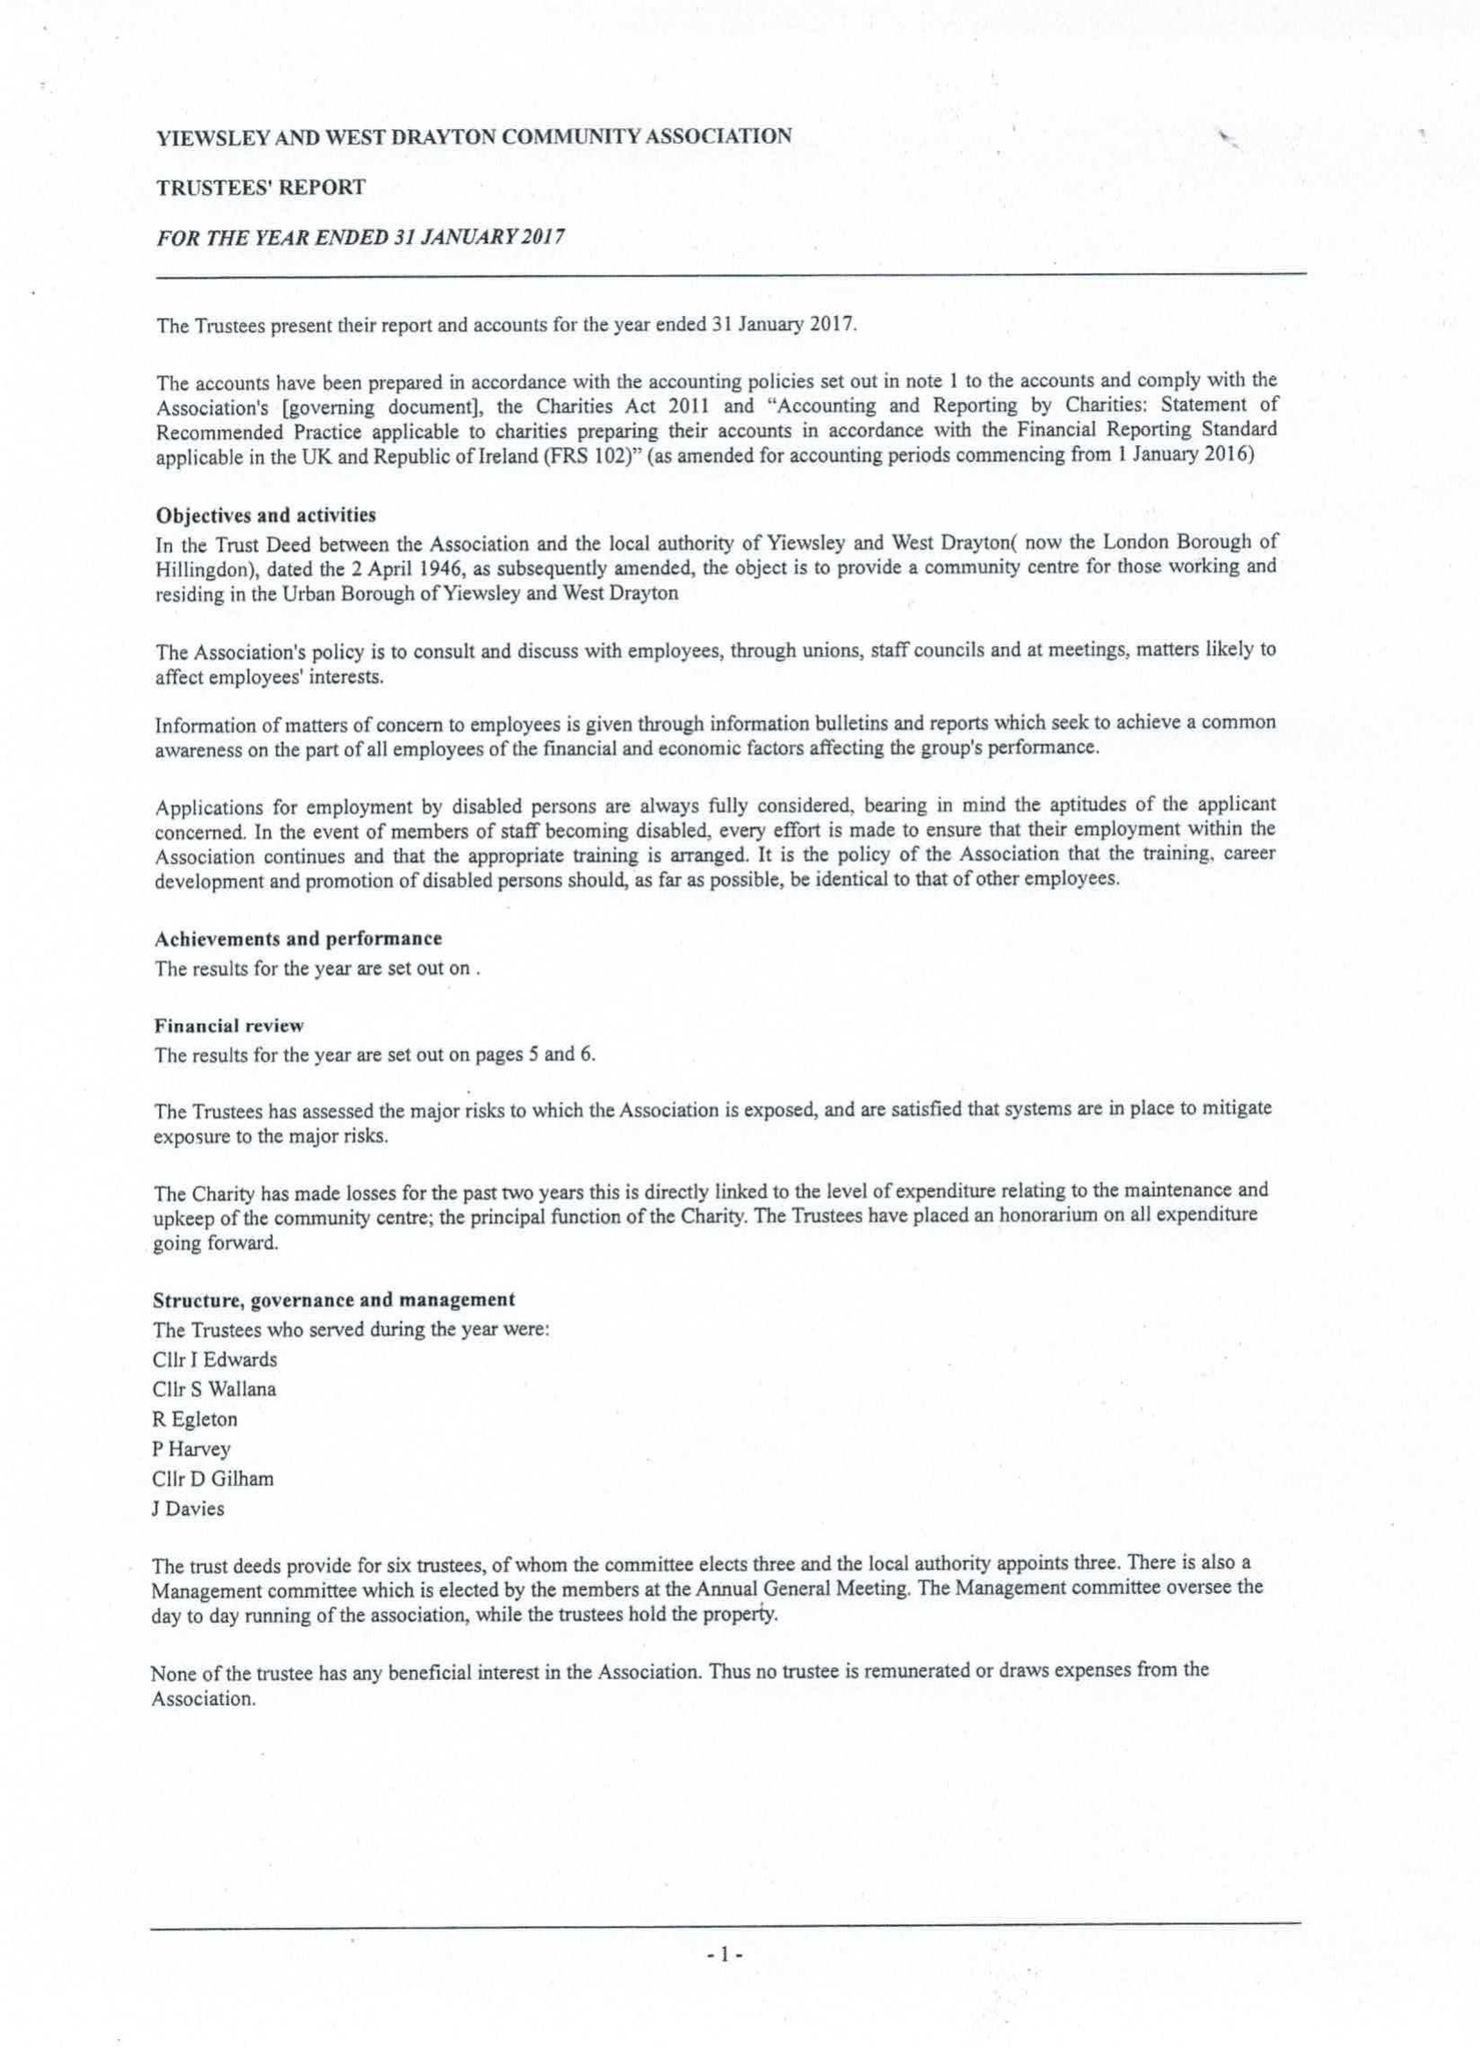What is the value for the address__postcode?
Answer the question using a single word or phrase. UB7 9JL 